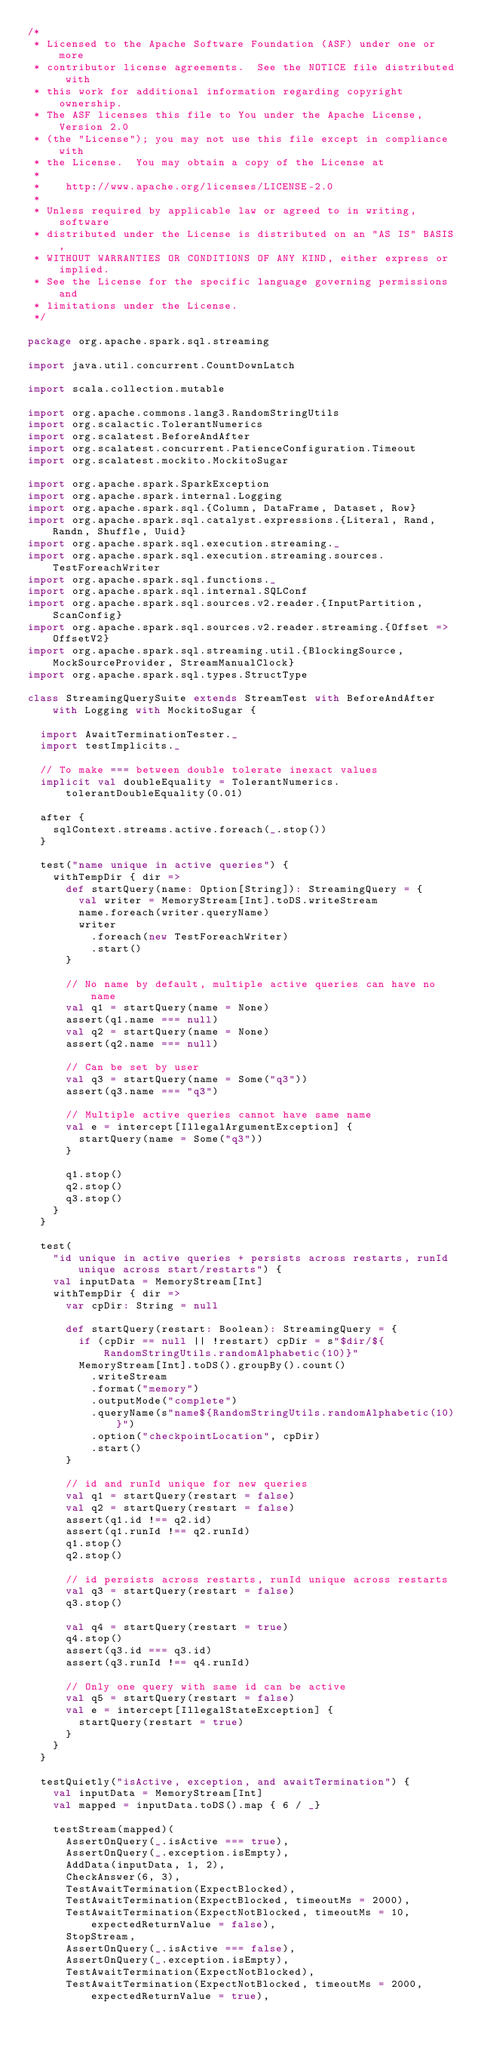<code> <loc_0><loc_0><loc_500><loc_500><_Scala_>/*
 * Licensed to the Apache Software Foundation (ASF) under one or more
 * contributor license agreements.  See the NOTICE file distributed with
 * this work for additional information regarding copyright ownership.
 * The ASF licenses this file to You under the Apache License, Version 2.0
 * (the "License"); you may not use this file except in compliance with
 * the License.  You may obtain a copy of the License at
 *
 *    http://www.apache.org/licenses/LICENSE-2.0
 *
 * Unless required by applicable law or agreed to in writing, software
 * distributed under the License is distributed on an "AS IS" BASIS,
 * WITHOUT WARRANTIES OR CONDITIONS OF ANY KIND, either express or implied.
 * See the License for the specific language governing permissions and
 * limitations under the License.
 */

package org.apache.spark.sql.streaming

import java.util.concurrent.CountDownLatch

import scala.collection.mutable

import org.apache.commons.lang3.RandomStringUtils
import org.scalactic.TolerantNumerics
import org.scalatest.BeforeAndAfter
import org.scalatest.concurrent.PatienceConfiguration.Timeout
import org.scalatest.mockito.MockitoSugar

import org.apache.spark.SparkException
import org.apache.spark.internal.Logging
import org.apache.spark.sql.{Column, DataFrame, Dataset, Row}
import org.apache.spark.sql.catalyst.expressions.{Literal, Rand, Randn, Shuffle, Uuid}
import org.apache.spark.sql.execution.streaming._
import org.apache.spark.sql.execution.streaming.sources.TestForeachWriter
import org.apache.spark.sql.functions._
import org.apache.spark.sql.internal.SQLConf
import org.apache.spark.sql.sources.v2.reader.{InputPartition, ScanConfig}
import org.apache.spark.sql.sources.v2.reader.streaming.{Offset => OffsetV2}
import org.apache.spark.sql.streaming.util.{BlockingSource, MockSourceProvider, StreamManualClock}
import org.apache.spark.sql.types.StructType

class StreamingQuerySuite extends StreamTest with BeforeAndAfter with Logging with MockitoSugar {

  import AwaitTerminationTester._
  import testImplicits._

  // To make === between double tolerate inexact values
  implicit val doubleEquality = TolerantNumerics.tolerantDoubleEquality(0.01)

  after {
    sqlContext.streams.active.foreach(_.stop())
  }

  test("name unique in active queries") {
    withTempDir { dir =>
      def startQuery(name: Option[String]): StreamingQuery = {
        val writer = MemoryStream[Int].toDS.writeStream
        name.foreach(writer.queryName)
        writer
          .foreach(new TestForeachWriter)
          .start()
      }

      // No name by default, multiple active queries can have no name
      val q1 = startQuery(name = None)
      assert(q1.name === null)
      val q2 = startQuery(name = None)
      assert(q2.name === null)

      // Can be set by user
      val q3 = startQuery(name = Some("q3"))
      assert(q3.name === "q3")

      // Multiple active queries cannot have same name
      val e = intercept[IllegalArgumentException] {
        startQuery(name = Some("q3"))
      }

      q1.stop()
      q2.stop()
      q3.stop()
    }
  }

  test(
    "id unique in active queries + persists across restarts, runId unique across start/restarts") {
    val inputData = MemoryStream[Int]
    withTempDir { dir =>
      var cpDir: String = null

      def startQuery(restart: Boolean): StreamingQuery = {
        if (cpDir == null || !restart) cpDir = s"$dir/${RandomStringUtils.randomAlphabetic(10)}"
        MemoryStream[Int].toDS().groupBy().count()
          .writeStream
          .format("memory")
          .outputMode("complete")
          .queryName(s"name${RandomStringUtils.randomAlphabetic(10)}")
          .option("checkpointLocation", cpDir)
          .start()
      }

      // id and runId unique for new queries
      val q1 = startQuery(restart = false)
      val q2 = startQuery(restart = false)
      assert(q1.id !== q2.id)
      assert(q1.runId !== q2.runId)
      q1.stop()
      q2.stop()

      // id persists across restarts, runId unique across restarts
      val q3 = startQuery(restart = false)
      q3.stop()

      val q4 = startQuery(restart = true)
      q4.stop()
      assert(q3.id === q3.id)
      assert(q3.runId !== q4.runId)

      // Only one query with same id can be active
      val q5 = startQuery(restart = false)
      val e = intercept[IllegalStateException] {
        startQuery(restart = true)
      }
    }
  }

  testQuietly("isActive, exception, and awaitTermination") {
    val inputData = MemoryStream[Int]
    val mapped = inputData.toDS().map { 6 / _}

    testStream(mapped)(
      AssertOnQuery(_.isActive === true),
      AssertOnQuery(_.exception.isEmpty),
      AddData(inputData, 1, 2),
      CheckAnswer(6, 3),
      TestAwaitTermination(ExpectBlocked),
      TestAwaitTermination(ExpectBlocked, timeoutMs = 2000),
      TestAwaitTermination(ExpectNotBlocked, timeoutMs = 10, expectedReturnValue = false),
      StopStream,
      AssertOnQuery(_.isActive === false),
      AssertOnQuery(_.exception.isEmpty),
      TestAwaitTermination(ExpectNotBlocked),
      TestAwaitTermination(ExpectNotBlocked, timeoutMs = 2000, expectedReturnValue = true),</code> 